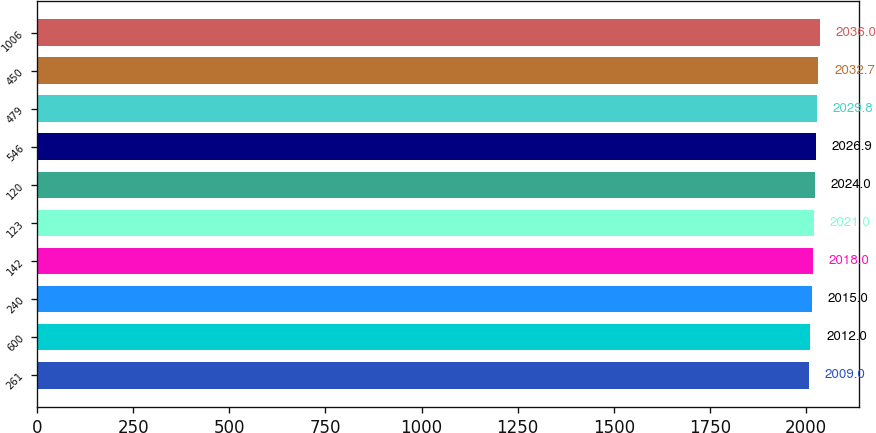Convert chart. <chart><loc_0><loc_0><loc_500><loc_500><bar_chart><fcel>261<fcel>600<fcel>240<fcel>142<fcel>123<fcel>120<fcel>546<fcel>479<fcel>450<fcel>1006<nl><fcel>2009<fcel>2012<fcel>2015<fcel>2018<fcel>2021<fcel>2024<fcel>2026.9<fcel>2029.8<fcel>2032.7<fcel>2036<nl></chart> 